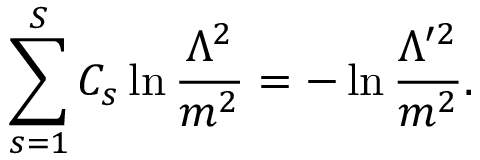Convert formula to latex. <formula><loc_0><loc_0><loc_500><loc_500>\sum _ { s = 1 } ^ { S } C _ { s } \ln \frac { \Lambda ^ { 2 } } { m ^ { 2 } } = - \ln \frac { \Lambda ^ { \prime 2 } } { m ^ { 2 } } .</formula> 